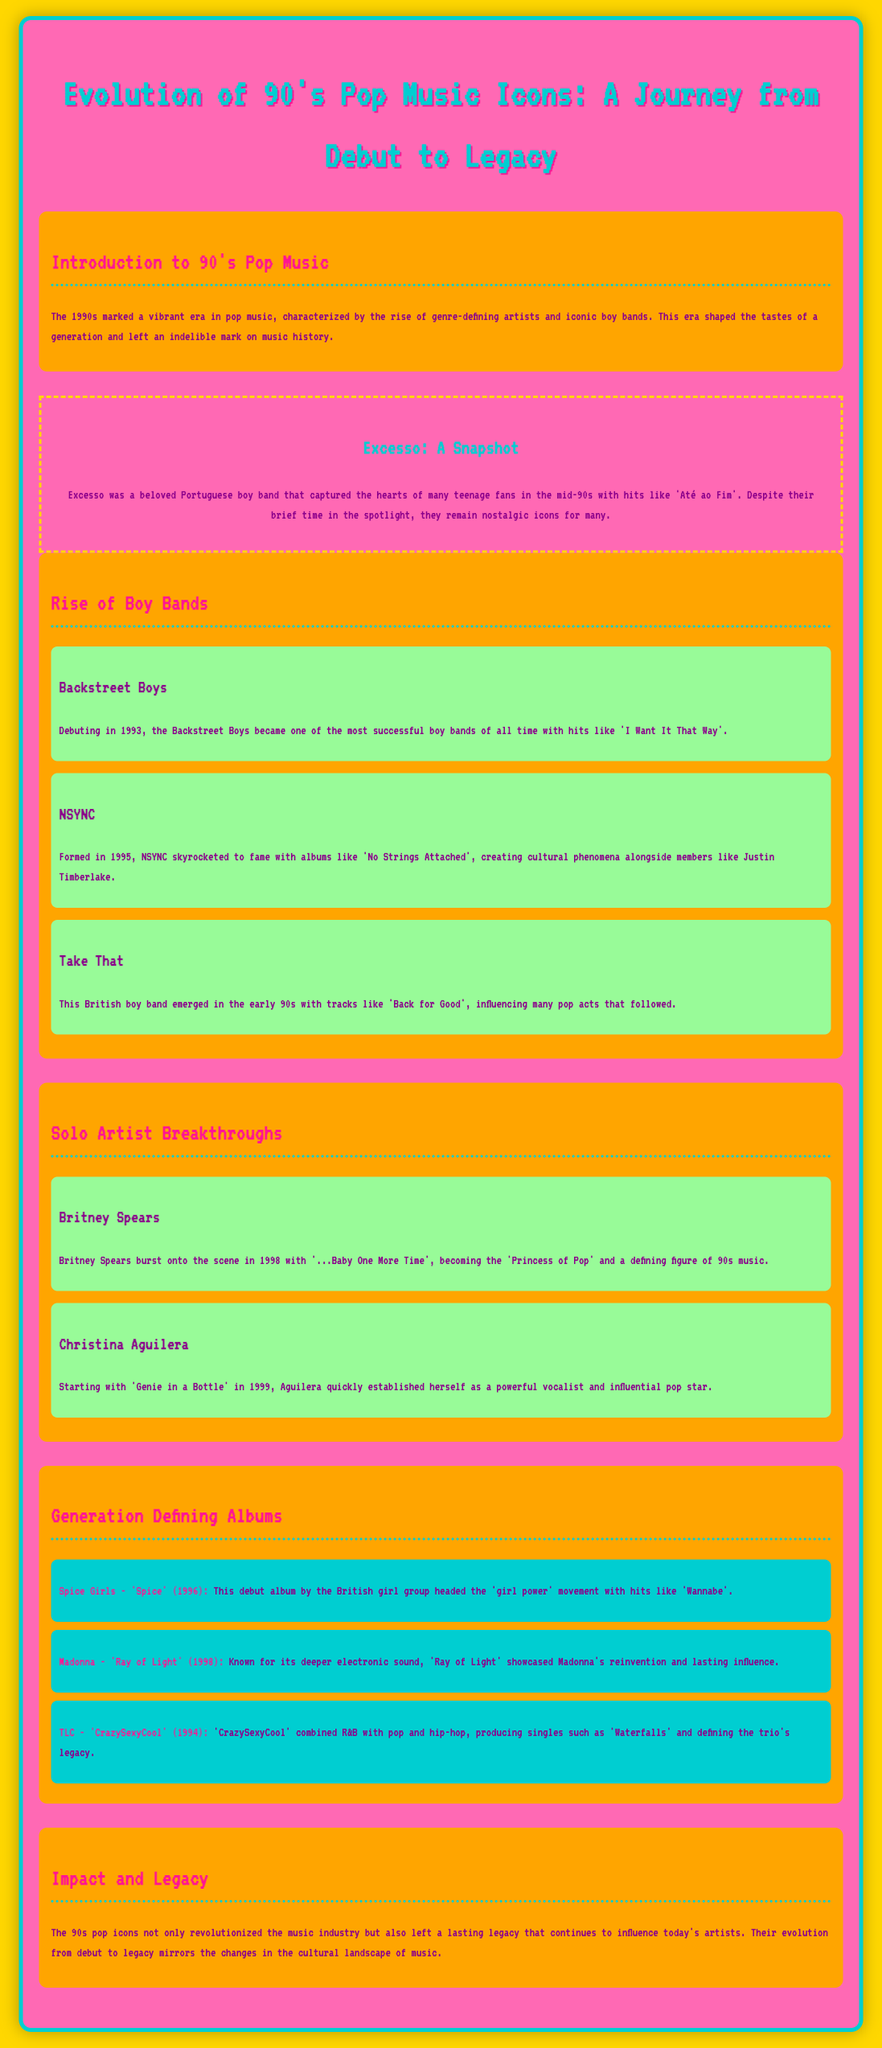what year did the Backstreet Boys debut? The Backstreet Boys debuted in 1993, as mentioned in the document.
Answer: 1993 what is the title of Britney Spears' debut single? Britney Spears burst onto the scene with '...Baby One More Time', which is highlighted in the document.
Answer: ...Baby One More Time which album is associated with the Spice Girls? The infographic mentions the album 'Spice' released in 1996, linked to the Spice Girls.
Answer: Spice who is referred to as the 'Princess of Pop'? The document identifies Britney Spears as the 'Princess of Pop'.
Answer: Britney Spears when was NSYNC formed? According to the document, NSYNC was formed in 1995.
Answer: 1995 what genre did TLC combine with pop and hip-hop? The document states that TLC combined R&B with pop and hip-hop in their album 'CrazySexyCool'.
Answer: R&B which boy band is associated with the hit 'Back for Good'? Take That is identified in the document as the boy band associated with the hit 'Back for Good'.
Answer: Take That what cultural movement did the Spice Girls' album head? The document mentions that the Spice Girls' debut album headed the 'girl power' movement.
Answer: girl power what is the legacy of 90’s pop icons according to the document? The document outlines that the 90s pop icons left a lasting legacy influencing today's artists.
Answer: lasting legacy 